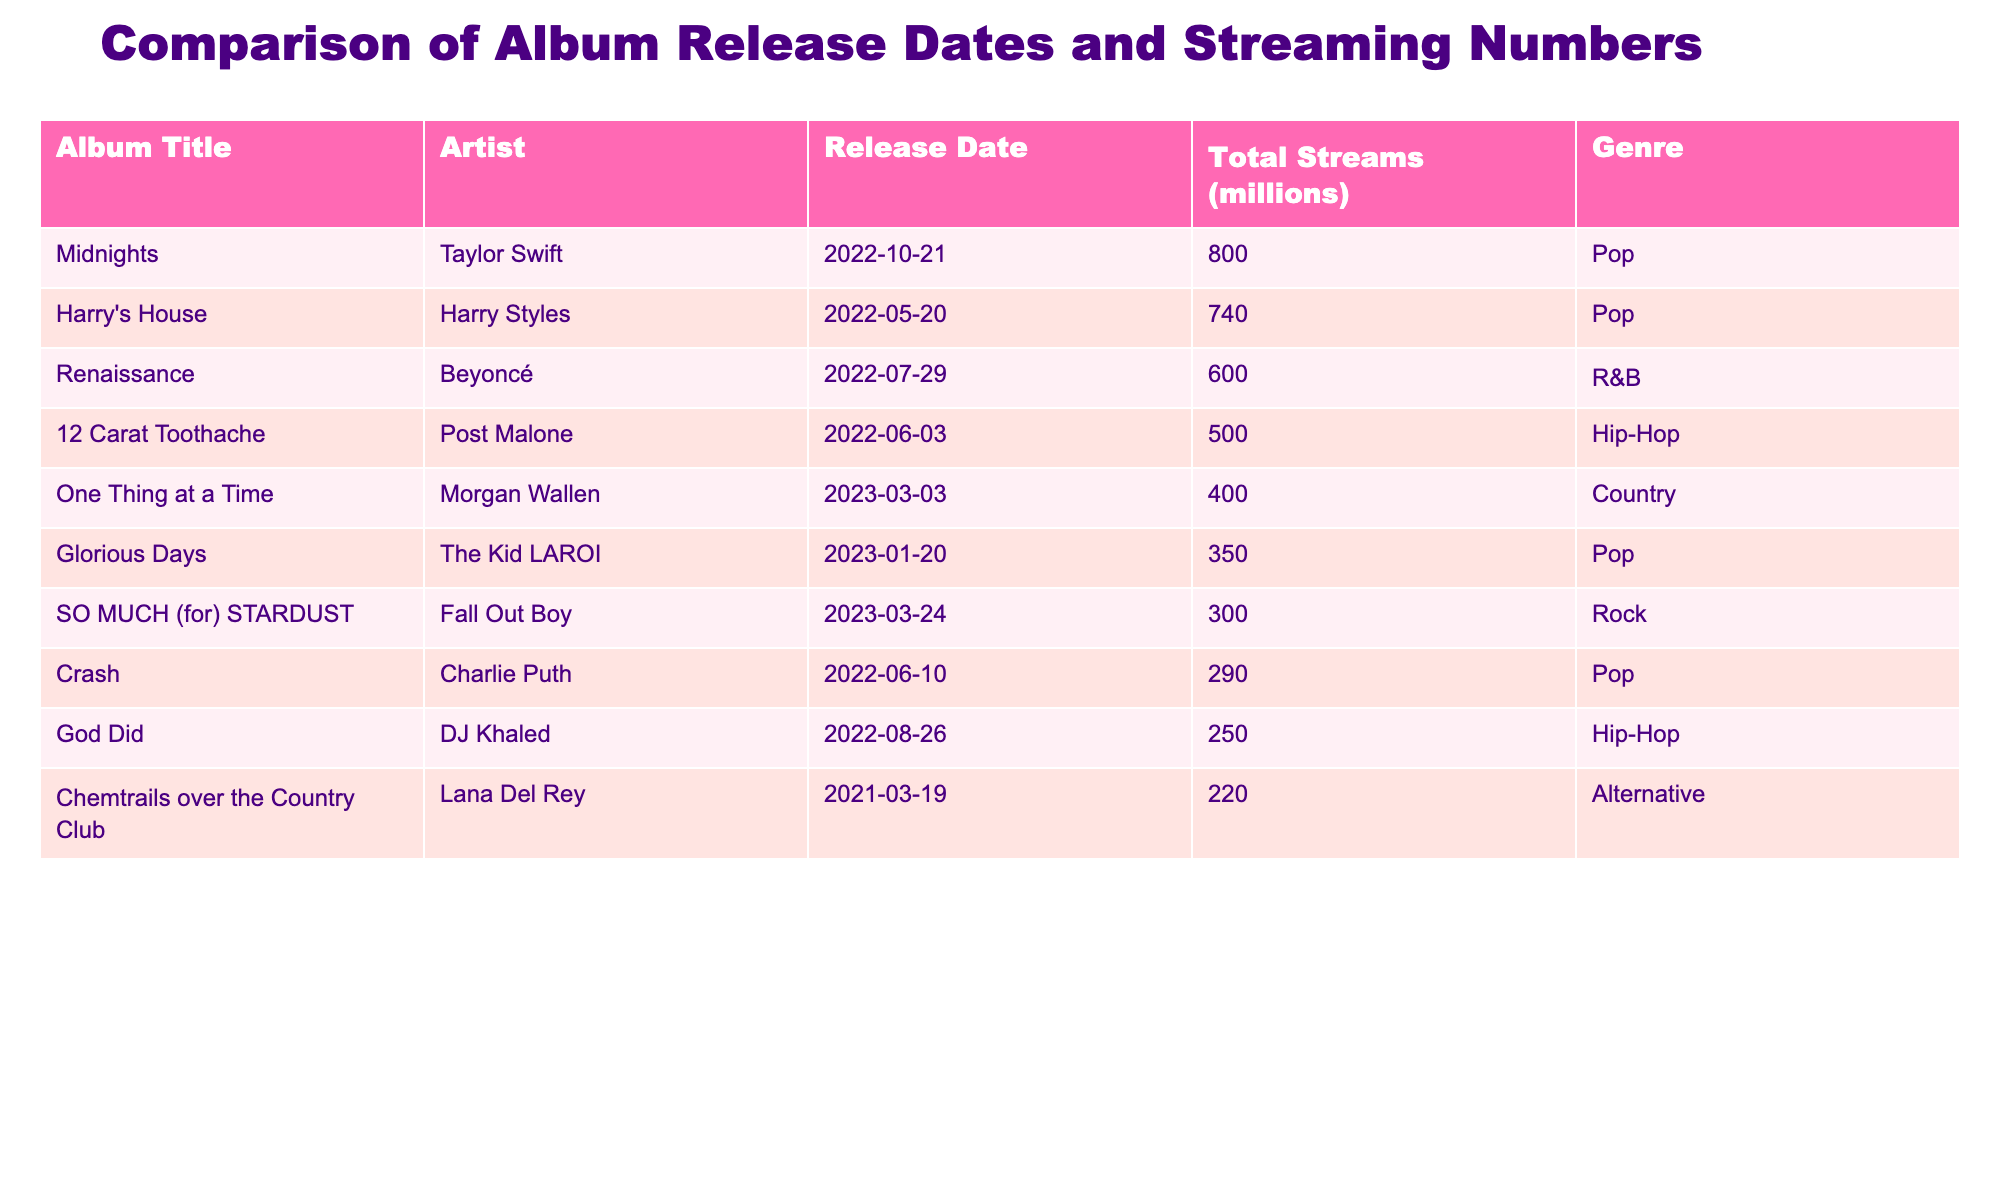What is the total number of streams for "Midnights"? The total streams for "Midnights" can be directly found in the table under the "Total Streams (millions)" column next to the album title. The value is 800 million.
Answer: 800 million Which album has the highest total streams? By reviewing the "Total Streams (millions)" column, "Midnights" has the highest number at 800 million, more than any other album listed.
Answer: "Midnights" How many streams do the albums by Taylor Swift and Harry Styles have together? The streams for "Midnights" and "Harry's House" are 800 million and 740 million respectively. Adding these gives 800 + 740 = 1540 million.
Answer: 1540 million Is "Renaissance" a Pop album? Looking at the genre for "Renaissance", which is listed as "R&B", we can conclude that it is not a Pop album.
Answer: No Which genre has the most albums listed? Reviewing the genre for all albums, both "Pop" and "Hip-Hop" have three entries, while the others have one or two. By comparing the totals for each genre, "Pop" and "Hip-Hop" are tied for the most.
Answer: Pop and Hip-Hop What is the average number of streams for the Hip-Hop albums in the table? The total streams for the Hip-Hop albums (Post Malone's "12 Carat Toothache" with 500 million and DJ Khaled's "God Did" with 250 million) are 500 + 250 = 750 million. There are two Hip-Hop albums, so the average is 750 / 2 = 375 million.
Answer: 375 million Are there more albums released in 2023 than in 2022? The table shows that there are three albums released in 2023 ("SO MUCH (for) STARDUST", "One Thing at a Time", and "Glorious Days") and five albums released in 2022. Thus, there are fewer albums released in 2023.
Answer: No What is the difference in total streams between "Glorious Days" and "Crash"? "Glorious Days" has 350 million streams and "Crash" has 290 million. Subtracting these gives 350 - 290 = 60 million, which shows how many more streams "Glorious Days" received over "Crash".
Answer: 60 million Which artist has released an album with fewer than 300 million streams? The albums with fewer than 300 million streams are "Crash" by Charlie Puth with 290 million and "God Did" by DJ Khaled with 250 million. Therefore, both Charlie Puth and DJ Khaled have released these albums.
Answer: Charlie Puth and DJ Khaled 